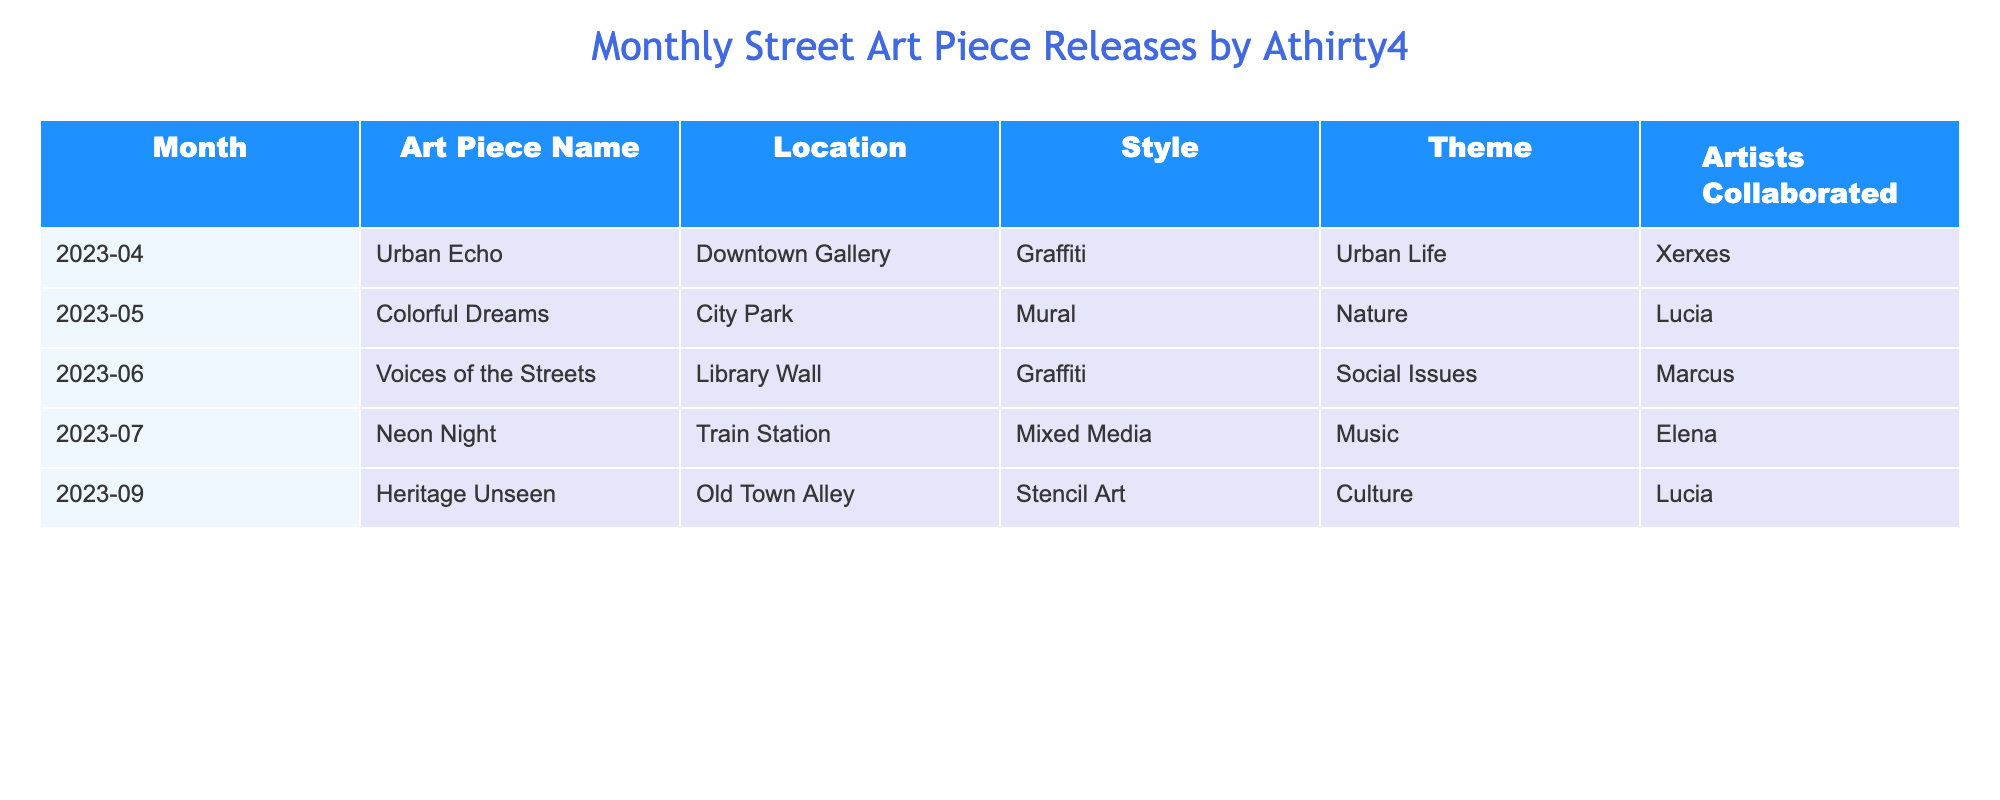What art piece was released in May 2023? Referring to the table, the row for May 2023 shows the art piece name "Colorful Dreams".
Answer: Colorful Dreams How many art pieces were released in total over the last six months? By counting the number of rows in the table, we find there are 5 entries, indicating 5 art pieces were released in total.
Answer: 5 Which theme is most frequently represented in the art pieces? Analyzing the theme column, "Urban Life" appears once, "Nature" appears once, "Social Issues" appears once, "Music" appears once, and "Culture" appears once. All themes are equally represented, therefore no specific theme is most frequent.
Answer: No specific theme Was any art piece created in collaboration with Marcus? Looking at the artists collaborated column, "Voices of the Streets" is associated with Marcus, confirming that at least one art piece was created in collaboration with him.
Answer: Yes Which month saw the release of the "Heritage Unseen" piece? The table indicates that "Heritage Unseen" was released in September 2023, as identified directly from its row.
Answer: September 2023 How many different styles are represented in the released art pieces? The styles listed include Graffiti (2), Mural (1), Mixed Media (1), and Stencil Art (1). Counting these distinct styles gives us a total of 4 different styles represented.
Answer: 4 Is there a piece that addresses social issues? The piece "Voices of the Streets" is categorized under the theme of Social Issues, confirming that there is indeed a piece that addresses this theme.
Answer: Yes What is the average release month when the art pieces were launched? The release months are April (4), May (5), June (6), July (7), and September (9). To find the average, we total these month values (4 + 5 + 6 + 7 + 9) = 31 and divide by the count (5). The average month is 31/5 = 6.2, so around June.
Answer: June (approximately) Which location had the highest number of art piece releases? Each location in the table is unique to an art piece, meaning no single location had more than one release. Therefore, every location has the same count of 1.
Answer: None, all unique locations 